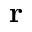Convert formula to latex. <formula><loc_0><loc_0><loc_500><loc_500>r</formula> 